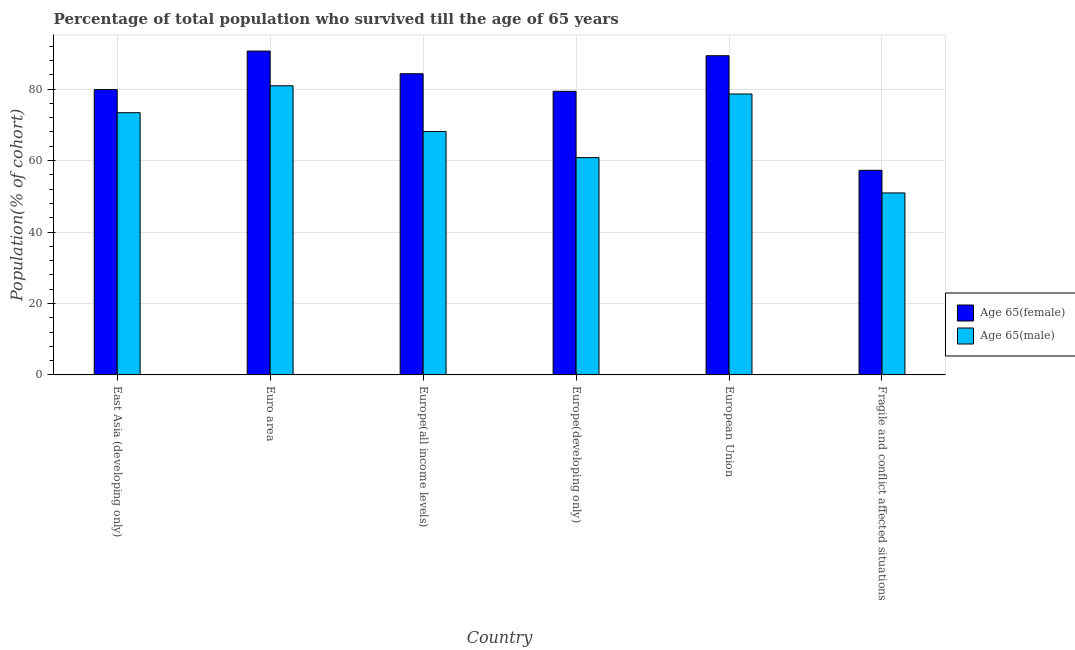Are the number of bars on each tick of the X-axis equal?
Provide a short and direct response. Yes. How many bars are there on the 1st tick from the left?
Offer a terse response. 2. What is the label of the 3rd group of bars from the left?
Make the answer very short. Europe(all income levels). What is the percentage of male population who survived till age of 65 in Fragile and conflict affected situations?
Give a very brief answer. 50.94. Across all countries, what is the maximum percentage of male population who survived till age of 65?
Offer a terse response. 80.93. Across all countries, what is the minimum percentage of female population who survived till age of 65?
Ensure brevity in your answer.  57.27. In which country was the percentage of female population who survived till age of 65 maximum?
Your response must be concise. Euro area. In which country was the percentage of male population who survived till age of 65 minimum?
Give a very brief answer. Fragile and conflict affected situations. What is the total percentage of male population who survived till age of 65 in the graph?
Provide a succinct answer. 412.85. What is the difference between the percentage of female population who survived till age of 65 in Europe(developing only) and that in European Union?
Your response must be concise. -9.96. What is the difference between the percentage of male population who survived till age of 65 in Euro area and the percentage of female population who survived till age of 65 in European Union?
Your response must be concise. -8.42. What is the average percentage of male population who survived till age of 65 per country?
Offer a very short reply. 68.81. What is the difference between the percentage of female population who survived till age of 65 and percentage of male population who survived till age of 65 in Fragile and conflict affected situations?
Your answer should be very brief. 6.33. What is the ratio of the percentage of male population who survived till age of 65 in Euro area to that in Europe(all income levels)?
Provide a succinct answer. 1.19. Is the percentage of female population who survived till age of 65 in Europe(all income levels) less than that in European Union?
Provide a short and direct response. Yes. What is the difference between the highest and the second highest percentage of female population who survived till age of 65?
Give a very brief answer. 1.3. What is the difference between the highest and the lowest percentage of male population who survived till age of 65?
Your answer should be compact. 29.99. In how many countries, is the percentage of female population who survived till age of 65 greater than the average percentage of female population who survived till age of 65 taken over all countries?
Your answer should be very brief. 3. What does the 2nd bar from the left in Fragile and conflict affected situations represents?
Your response must be concise. Age 65(male). What does the 1st bar from the right in Euro area represents?
Your response must be concise. Age 65(male). Does the graph contain grids?
Provide a succinct answer. Yes. Where does the legend appear in the graph?
Make the answer very short. Center right. How are the legend labels stacked?
Ensure brevity in your answer.  Vertical. What is the title of the graph?
Give a very brief answer. Percentage of total population who survived till the age of 65 years. What is the label or title of the X-axis?
Make the answer very short. Country. What is the label or title of the Y-axis?
Ensure brevity in your answer.  Population(% of cohort). What is the Population(% of cohort) in Age 65(female) in East Asia (developing only)?
Offer a terse response. 79.86. What is the Population(% of cohort) of Age 65(male) in East Asia (developing only)?
Your answer should be very brief. 73.4. What is the Population(% of cohort) of Age 65(female) in Euro area?
Give a very brief answer. 90.65. What is the Population(% of cohort) in Age 65(male) in Euro area?
Offer a very short reply. 80.93. What is the Population(% of cohort) in Age 65(female) in Europe(all income levels)?
Ensure brevity in your answer.  84.31. What is the Population(% of cohort) in Age 65(male) in Europe(all income levels)?
Your response must be concise. 68.12. What is the Population(% of cohort) in Age 65(female) in Europe(developing only)?
Make the answer very short. 79.38. What is the Population(% of cohort) in Age 65(male) in Europe(developing only)?
Your answer should be compact. 60.83. What is the Population(% of cohort) of Age 65(female) in European Union?
Your answer should be compact. 89.34. What is the Population(% of cohort) in Age 65(male) in European Union?
Offer a very short reply. 78.63. What is the Population(% of cohort) of Age 65(female) in Fragile and conflict affected situations?
Your response must be concise. 57.27. What is the Population(% of cohort) in Age 65(male) in Fragile and conflict affected situations?
Provide a succinct answer. 50.94. Across all countries, what is the maximum Population(% of cohort) of Age 65(female)?
Your answer should be very brief. 90.65. Across all countries, what is the maximum Population(% of cohort) in Age 65(male)?
Provide a short and direct response. 80.93. Across all countries, what is the minimum Population(% of cohort) in Age 65(female)?
Give a very brief answer. 57.27. Across all countries, what is the minimum Population(% of cohort) of Age 65(male)?
Give a very brief answer. 50.94. What is the total Population(% of cohort) in Age 65(female) in the graph?
Keep it short and to the point. 480.81. What is the total Population(% of cohort) in Age 65(male) in the graph?
Make the answer very short. 412.85. What is the difference between the Population(% of cohort) of Age 65(female) in East Asia (developing only) and that in Euro area?
Your response must be concise. -10.79. What is the difference between the Population(% of cohort) in Age 65(male) in East Asia (developing only) and that in Euro area?
Keep it short and to the point. -7.53. What is the difference between the Population(% of cohort) in Age 65(female) in East Asia (developing only) and that in Europe(all income levels)?
Keep it short and to the point. -4.44. What is the difference between the Population(% of cohort) in Age 65(male) in East Asia (developing only) and that in Europe(all income levels)?
Give a very brief answer. 5.28. What is the difference between the Population(% of cohort) in Age 65(female) in East Asia (developing only) and that in Europe(developing only)?
Keep it short and to the point. 0.48. What is the difference between the Population(% of cohort) in Age 65(male) in East Asia (developing only) and that in Europe(developing only)?
Your answer should be compact. 12.57. What is the difference between the Population(% of cohort) in Age 65(female) in East Asia (developing only) and that in European Union?
Provide a succinct answer. -9.48. What is the difference between the Population(% of cohort) of Age 65(male) in East Asia (developing only) and that in European Union?
Your answer should be very brief. -5.23. What is the difference between the Population(% of cohort) in Age 65(female) in East Asia (developing only) and that in Fragile and conflict affected situations?
Keep it short and to the point. 22.59. What is the difference between the Population(% of cohort) in Age 65(male) in East Asia (developing only) and that in Fragile and conflict affected situations?
Make the answer very short. 22.46. What is the difference between the Population(% of cohort) in Age 65(female) in Euro area and that in Europe(all income levels)?
Your answer should be compact. 6.34. What is the difference between the Population(% of cohort) of Age 65(male) in Euro area and that in Europe(all income levels)?
Give a very brief answer. 12.8. What is the difference between the Population(% of cohort) in Age 65(female) in Euro area and that in Europe(developing only)?
Give a very brief answer. 11.27. What is the difference between the Population(% of cohort) in Age 65(male) in Euro area and that in Europe(developing only)?
Provide a succinct answer. 20.1. What is the difference between the Population(% of cohort) in Age 65(female) in Euro area and that in European Union?
Your answer should be compact. 1.3. What is the difference between the Population(% of cohort) in Age 65(male) in Euro area and that in European Union?
Your response must be concise. 2.29. What is the difference between the Population(% of cohort) in Age 65(female) in Euro area and that in Fragile and conflict affected situations?
Give a very brief answer. 33.38. What is the difference between the Population(% of cohort) in Age 65(male) in Euro area and that in Fragile and conflict affected situations?
Make the answer very short. 29.99. What is the difference between the Population(% of cohort) in Age 65(female) in Europe(all income levels) and that in Europe(developing only)?
Give a very brief answer. 4.92. What is the difference between the Population(% of cohort) in Age 65(male) in Europe(all income levels) and that in Europe(developing only)?
Make the answer very short. 7.3. What is the difference between the Population(% of cohort) in Age 65(female) in Europe(all income levels) and that in European Union?
Ensure brevity in your answer.  -5.04. What is the difference between the Population(% of cohort) of Age 65(male) in Europe(all income levels) and that in European Union?
Make the answer very short. -10.51. What is the difference between the Population(% of cohort) in Age 65(female) in Europe(all income levels) and that in Fragile and conflict affected situations?
Provide a succinct answer. 27.04. What is the difference between the Population(% of cohort) of Age 65(male) in Europe(all income levels) and that in Fragile and conflict affected situations?
Offer a very short reply. 17.19. What is the difference between the Population(% of cohort) of Age 65(female) in Europe(developing only) and that in European Union?
Make the answer very short. -9.96. What is the difference between the Population(% of cohort) in Age 65(male) in Europe(developing only) and that in European Union?
Give a very brief answer. -17.81. What is the difference between the Population(% of cohort) of Age 65(female) in Europe(developing only) and that in Fragile and conflict affected situations?
Make the answer very short. 22.11. What is the difference between the Population(% of cohort) in Age 65(male) in Europe(developing only) and that in Fragile and conflict affected situations?
Give a very brief answer. 9.89. What is the difference between the Population(% of cohort) in Age 65(female) in European Union and that in Fragile and conflict affected situations?
Provide a short and direct response. 32.07. What is the difference between the Population(% of cohort) of Age 65(male) in European Union and that in Fragile and conflict affected situations?
Provide a short and direct response. 27.7. What is the difference between the Population(% of cohort) of Age 65(female) in East Asia (developing only) and the Population(% of cohort) of Age 65(male) in Euro area?
Your answer should be very brief. -1.06. What is the difference between the Population(% of cohort) in Age 65(female) in East Asia (developing only) and the Population(% of cohort) in Age 65(male) in Europe(all income levels)?
Your answer should be compact. 11.74. What is the difference between the Population(% of cohort) of Age 65(female) in East Asia (developing only) and the Population(% of cohort) of Age 65(male) in Europe(developing only)?
Give a very brief answer. 19.04. What is the difference between the Population(% of cohort) of Age 65(female) in East Asia (developing only) and the Population(% of cohort) of Age 65(male) in European Union?
Provide a succinct answer. 1.23. What is the difference between the Population(% of cohort) of Age 65(female) in East Asia (developing only) and the Population(% of cohort) of Age 65(male) in Fragile and conflict affected situations?
Your response must be concise. 28.92. What is the difference between the Population(% of cohort) of Age 65(female) in Euro area and the Population(% of cohort) of Age 65(male) in Europe(all income levels)?
Provide a short and direct response. 22.53. What is the difference between the Population(% of cohort) of Age 65(female) in Euro area and the Population(% of cohort) of Age 65(male) in Europe(developing only)?
Your answer should be compact. 29.82. What is the difference between the Population(% of cohort) of Age 65(female) in Euro area and the Population(% of cohort) of Age 65(male) in European Union?
Keep it short and to the point. 12.01. What is the difference between the Population(% of cohort) in Age 65(female) in Euro area and the Population(% of cohort) in Age 65(male) in Fragile and conflict affected situations?
Make the answer very short. 39.71. What is the difference between the Population(% of cohort) of Age 65(female) in Europe(all income levels) and the Population(% of cohort) of Age 65(male) in Europe(developing only)?
Your response must be concise. 23.48. What is the difference between the Population(% of cohort) in Age 65(female) in Europe(all income levels) and the Population(% of cohort) in Age 65(male) in European Union?
Offer a very short reply. 5.67. What is the difference between the Population(% of cohort) in Age 65(female) in Europe(all income levels) and the Population(% of cohort) in Age 65(male) in Fragile and conflict affected situations?
Your answer should be very brief. 33.37. What is the difference between the Population(% of cohort) in Age 65(female) in Europe(developing only) and the Population(% of cohort) in Age 65(male) in European Union?
Your response must be concise. 0.75. What is the difference between the Population(% of cohort) in Age 65(female) in Europe(developing only) and the Population(% of cohort) in Age 65(male) in Fragile and conflict affected situations?
Give a very brief answer. 28.44. What is the difference between the Population(% of cohort) of Age 65(female) in European Union and the Population(% of cohort) of Age 65(male) in Fragile and conflict affected situations?
Keep it short and to the point. 38.41. What is the average Population(% of cohort) of Age 65(female) per country?
Your response must be concise. 80.14. What is the average Population(% of cohort) of Age 65(male) per country?
Make the answer very short. 68.81. What is the difference between the Population(% of cohort) of Age 65(female) and Population(% of cohort) of Age 65(male) in East Asia (developing only)?
Your answer should be compact. 6.46. What is the difference between the Population(% of cohort) of Age 65(female) and Population(% of cohort) of Age 65(male) in Euro area?
Your response must be concise. 9.72. What is the difference between the Population(% of cohort) of Age 65(female) and Population(% of cohort) of Age 65(male) in Europe(all income levels)?
Your response must be concise. 16.18. What is the difference between the Population(% of cohort) in Age 65(female) and Population(% of cohort) in Age 65(male) in Europe(developing only)?
Your answer should be very brief. 18.56. What is the difference between the Population(% of cohort) of Age 65(female) and Population(% of cohort) of Age 65(male) in European Union?
Your answer should be compact. 10.71. What is the difference between the Population(% of cohort) of Age 65(female) and Population(% of cohort) of Age 65(male) in Fragile and conflict affected situations?
Give a very brief answer. 6.33. What is the ratio of the Population(% of cohort) in Age 65(female) in East Asia (developing only) to that in Euro area?
Give a very brief answer. 0.88. What is the ratio of the Population(% of cohort) in Age 65(male) in East Asia (developing only) to that in Euro area?
Provide a succinct answer. 0.91. What is the ratio of the Population(% of cohort) of Age 65(female) in East Asia (developing only) to that in Europe(all income levels)?
Your response must be concise. 0.95. What is the ratio of the Population(% of cohort) of Age 65(male) in East Asia (developing only) to that in Europe(all income levels)?
Offer a terse response. 1.08. What is the ratio of the Population(% of cohort) of Age 65(female) in East Asia (developing only) to that in Europe(developing only)?
Offer a terse response. 1.01. What is the ratio of the Population(% of cohort) of Age 65(male) in East Asia (developing only) to that in Europe(developing only)?
Provide a short and direct response. 1.21. What is the ratio of the Population(% of cohort) of Age 65(female) in East Asia (developing only) to that in European Union?
Offer a terse response. 0.89. What is the ratio of the Population(% of cohort) of Age 65(male) in East Asia (developing only) to that in European Union?
Provide a succinct answer. 0.93. What is the ratio of the Population(% of cohort) in Age 65(female) in East Asia (developing only) to that in Fragile and conflict affected situations?
Provide a succinct answer. 1.39. What is the ratio of the Population(% of cohort) in Age 65(male) in East Asia (developing only) to that in Fragile and conflict affected situations?
Your answer should be very brief. 1.44. What is the ratio of the Population(% of cohort) in Age 65(female) in Euro area to that in Europe(all income levels)?
Ensure brevity in your answer.  1.08. What is the ratio of the Population(% of cohort) of Age 65(male) in Euro area to that in Europe(all income levels)?
Your answer should be very brief. 1.19. What is the ratio of the Population(% of cohort) of Age 65(female) in Euro area to that in Europe(developing only)?
Provide a short and direct response. 1.14. What is the ratio of the Population(% of cohort) of Age 65(male) in Euro area to that in Europe(developing only)?
Offer a very short reply. 1.33. What is the ratio of the Population(% of cohort) of Age 65(female) in Euro area to that in European Union?
Your answer should be compact. 1.01. What is the ratio of the Population(% of cohort) in Age 65(male) in Euro area to that in European Union?
Give a very brief answer. 1.03. What is the ratio of the Population(% of cohort) in Age 65(female) in Euro area to that in Fragile and conflict affected situations?
Provide a succinct answer. 1.58. What is the ratio of the Population(% of cohort) of Age 65(male) in Euro area to that in Fragile and conflict affected situations?
Ensure brevity in your answer.  1.59. What is the ratio of the Population(% of cohort) of Age 65(female) in Europe(all income levels) to that in Europe(developing only)?
Make the answer very short. 1.06. What is the ratio of the Population(% of cohort) in Age 65(male) in Europe(all income levels) to that in Europe(developing only)?
Your answer should be very brief. 1.12. What is the ratio of the Population(% of cohort) of Age 65(female) in Europe(all income levels) to that in European Union?
Ensure brevity in your answer.  0.94. What is the ratio of the Population(% of cohort) in Age 65(male) in Europe(all income levels) to that in European Union?
Your answer should be compact. 0.87. What is the ratio of the Population(% of cohort) of Age 65(female) in Europe(all income levels) to that in Fragile and conflict affected situations?
Your answer should be very brief. 1.47. What is the ratio of the Population(% of cohort) in Age 65(male) in Europe(all income levels) to that in Fragile and conflict affected situations?
Provide a succinct answer. 1.34. What is the ratio of the Population(% of cohort) in Age 65(female) in Europe(developing only) to that in European Union?
Offer a very short reply. 0.89. What is the ratio of the Population(% of cohort) of Age 65(male) in Europe(developing only) to that in European Union?
Offer a very short reply. 0.77. What is the ratio of the Population(% of cohort) of Age 65(female) in Europe(developing only) to that in Fragile and conflict affected situations?
Offer a terse response. 1.39. What is the ratio of the Population(% of cohort) of Age 65(male) in Europe(developing only) to that in Fragile and conflict affected situations?
Keep it short and to the point. 1.19. What is the ratio of the Population(% of cohort) in Age 65(female) in European Union to that in Fragile and conflict affected situations?
Keep it short and to the point. 1.56. What is the ratio of the Population(% of cohort) in Age 65(male) in European Union to that in Fragile and conflict affected situations?
Provide a short and direct response. 1.54. What is the difference between the highest and the second highest Population(% of cohort) in Age 65(female)?
Keep it short and to the point. 1.3. What is the difference between the highest and the second highest Population(% of cohort) of Age 65(male)?
Give a very brief answer. 2.29. What is the difference between the highest and the lowest Population(% of cohort) of Age 65(female)?
Offer a terse response. 33.38. What is the difference between the highest and the lowest Population(% of cohort) in Age 65(male)?
Your answer should be very brief. 29.99. 